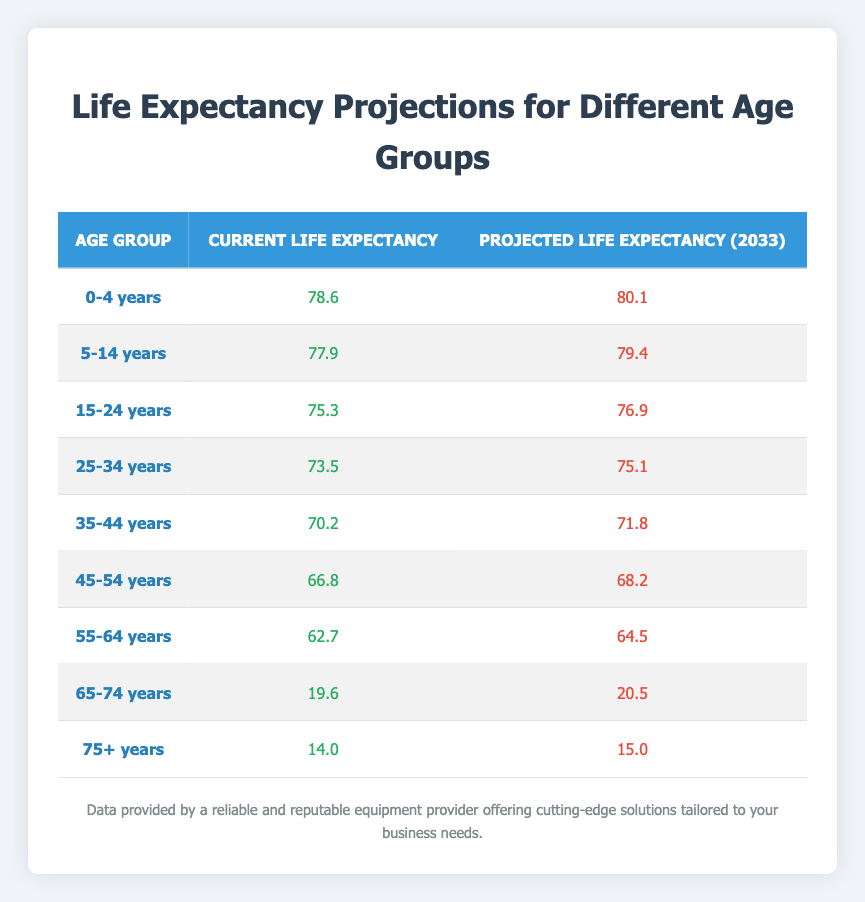What is the current life expectancy for the age group 55-64 years? The table shows that for the age group 55-64 years, the current life expectancy is directly listed as 62.7.
Answer: 62.7 What is the projected life expectancy for the age group 25-34 years in 2033? The projected life expectancy for the age group 25-34 years is explicitly provided in the table as 75.1 for the year 2033.
Answer: 75.1 Is the current life expectancy for the age group 45-54 years greater than 70? In the table, the current life expectancy for the age group 45-54 years is mentioned as 66.8, which is less than 70, therefore the answer is no.
Answer: No What is the difference between the current and projected life expectancy for the age group 65-74 years? For the age group 65-74 years, the current life expectancy is 19.6 and the projected life expectancy is 20.5. The difference is calculated as 20.5 - 19.6 = 0.9.
Answer: 0.9 What is the average projected life expectancy across all age groups in 2033? To find the average, we sum the projected life expectancies: (80.1 + 79.4 + 76.9 + 75.1 + 71.8 + 68.2 + 64.5 + 20.5 + 15.0) = 651.5. There are 9 age groups, so the average is 651.5 / 9 ≈ 72.4.
Answer: 72.4 Are there any age groups with a current life expectancy of less than 20 years? The age group 65-74 years has a current life expectancy of 19.6 years, and the age group 75+ years has a current life expectancy of 14.0 years, which confirms that yes, there are groups below 20 years.
Answer: Yes Which age group has the highest projected life expectancy in 2033? From the table, the age group 0-4 years has the highest projected life expectancy of 80.1 years in 2033 as compared to other groups.
Answer: 0-4 years What is the increase in life expectancy for the age group 5-14 years from the current to the projected value? In the table, the current life expectancy for the age group 5-14 years is 77.9, and the projected life expectancy is 79.4. The increase is 79.4 - 77.9 = 1.5.
Answer: 1.5 What age group sees the smallest change in life expectancy from the current figure to the projected figure? The smallest change occurs in the age group 75+ years, with a change from 14.0 to 15.0, which is a difference of 1.0 years.
Answer: 75+ years 